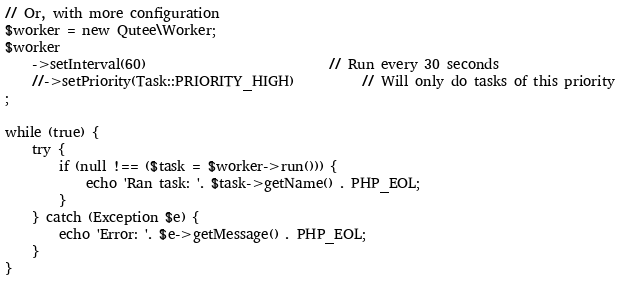<code> <loc_0><loc_0><loc_500><loc_500><_PHP_>
// Or, with more configuration
$worker = new Qutee\Worker;
$worker
    ->setInterval(60)                           // Run every 30 seconds
    //->setPriority(Task::PRIORITY_HIGH)          // Will only do tasks of this priority
;

while (true) {
    try {
        if (null !== ($task = $worker->run())) {
            echo 'Ran task: '. $task->getName() . PHP_EOL;
        }
    } catch (Exception $e) {
        echo 'Error: '. $e->getMessage() . PHP_EOL;
    }
}</code> 